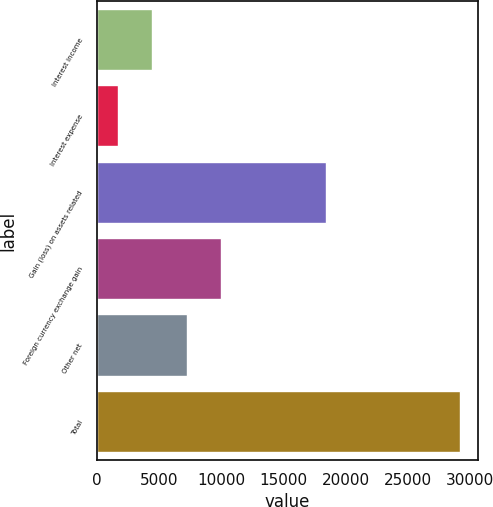Convert chart to OTSL. <chart><loc_0><loc_0><loc_500><loc_500><bar_chart><fcel>Interest income<fcel>Interest expense<fcel>Gain (loss) on assets related<fcel>Foreign currency exchange gain<fcel>Other net<fcel>Total<nl><fcel>4443.7<fcel>1696<fcel>18453<fcel>9939.1<fcel>7191.4<fcel>29173<nl></chart> 